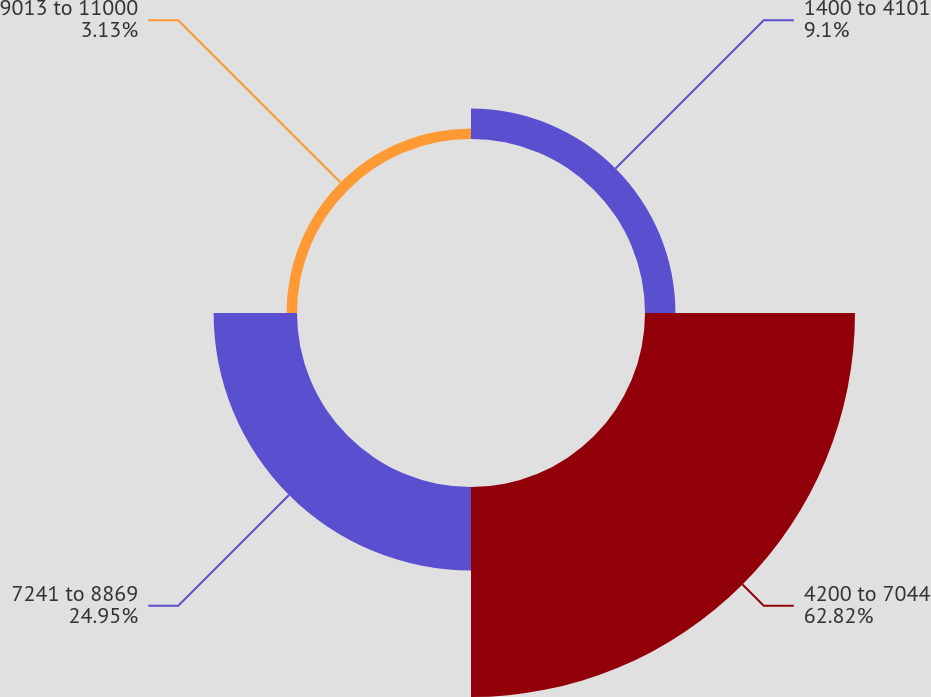Convert chart to OTSL. <chart><loc_0><loc_0><loc_500><loc_500><pie_chart><fcel>1400 to 4101<fcel>4200 to 7044<fcel>7241 to 8869<fcel>9013 to 11000<nl><fcel>9.1%<fcel>62.82%<fcel>24.95%<fcel>3.13%<nl></chart> 